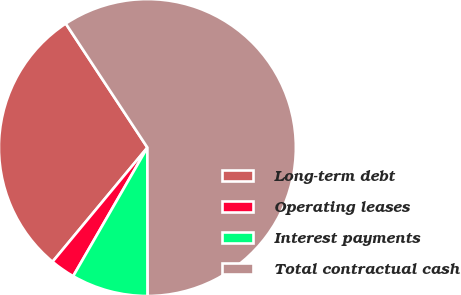Convert chart to OTSL. <chart><loc_0><loc_0><loc_500><loc_500><pie_chart><fcel>Long-term debt<fcel>Operating leases<fcel>Interest payments<fcel>Total contractual cash<nl><fcel>29.7%<fcel>2.7%<fcel>8.36%<fcel>59.24%<nl></chart> 